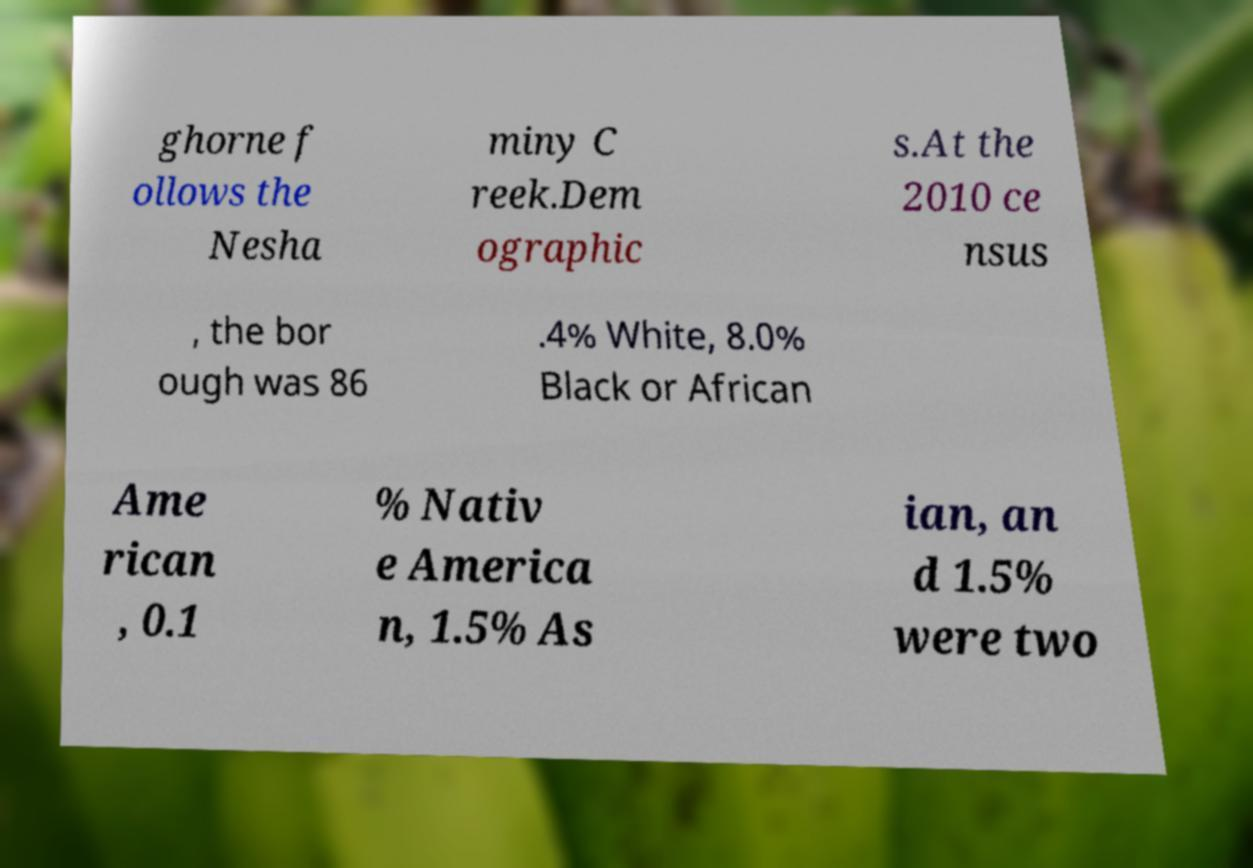Please identify and transcribe the text found in this image. ghorne f ollows the Nesha miny C reek.Dem ographic s.At the 2010 ce nsus , the bor ough was 86 .4% White, 8.0% Black or African Ame rican , 0.1 % Nativ e America n, 1.5% As ian, an d 1.5% were two 